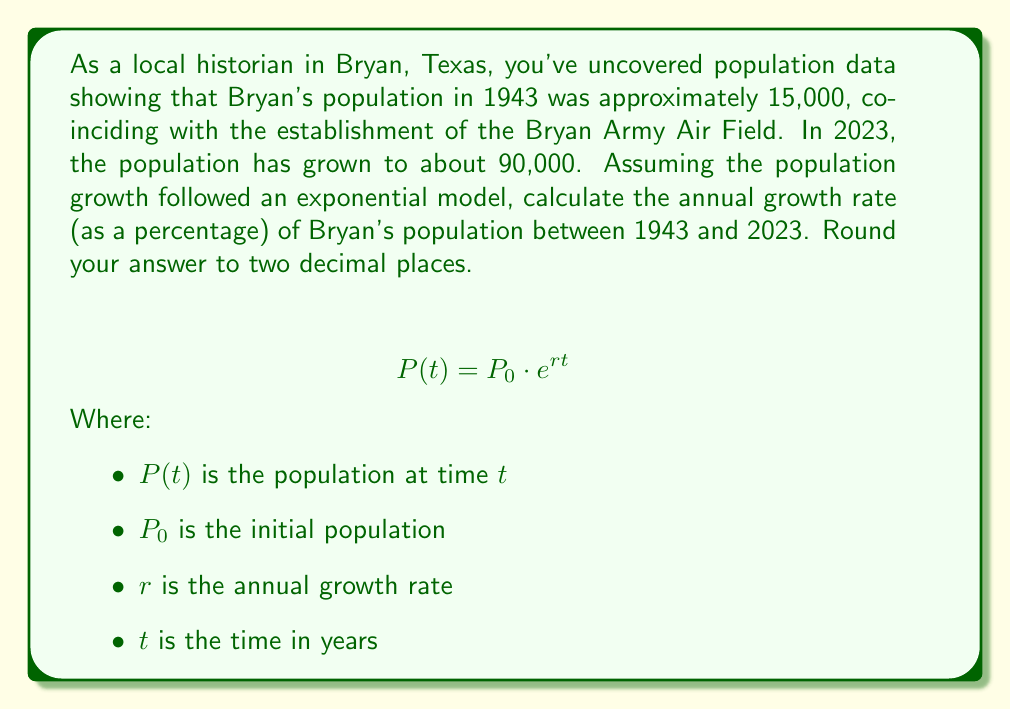What is the answer to this math problem? To solve this problem, we'll use the exponential growth formula and the given information:

1. Initial population in 1943 ($P_0$): 15,000
2. Final population in 2023 ($P(t)$): 90,000
3. Time period ($t$): 2023 - 1943 = 80 years

Let's plug these values into the exponential growth formula:

$$90,000 = 15,000 \cdot e^{80r}$$

Now, we'll solve for $r$:

1. Divide both sides by 15,000:
   $$6 = e^{80r}$$

2. Take the natural logarithm of both sides:
   $$\ln(6) = \ln(e^{80r})$$
   $$\ln(6) = 80r$$

3. Solve for $r$:
   $$r = \frac{\ln(6)}{80}$$
   $$r \approx 0.022375$$

4. Convert to a percentage and round to two decimal places:
   $$r \approx 0.022375 \times 100\% = 2.24\%$$

Therefore, the annual growth rate of Bryan's population between 1943 and 2023 was approximately 2.24%.
Answer: 2.24% 